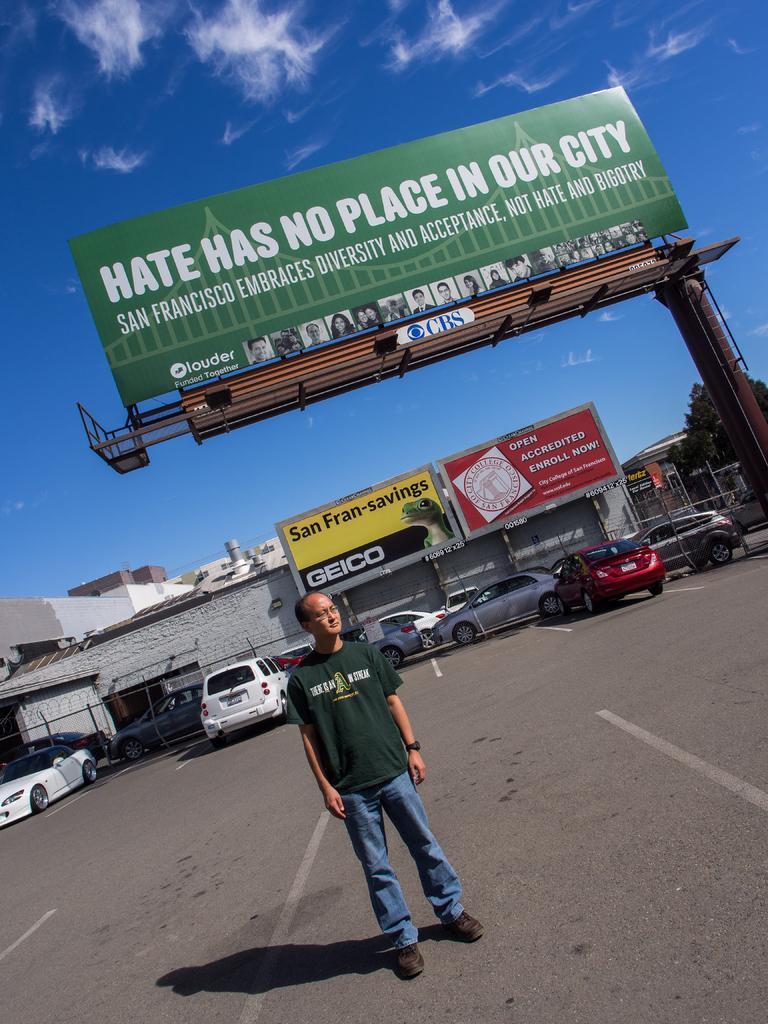How would you summarize this image in a sentence or two? In the center of the image there is a person wearing green color t-shirt standing on the road. At the background of the image there are many cars. There is a building. There is a big hoarding at the background of the image. At the top the image there is sky. 